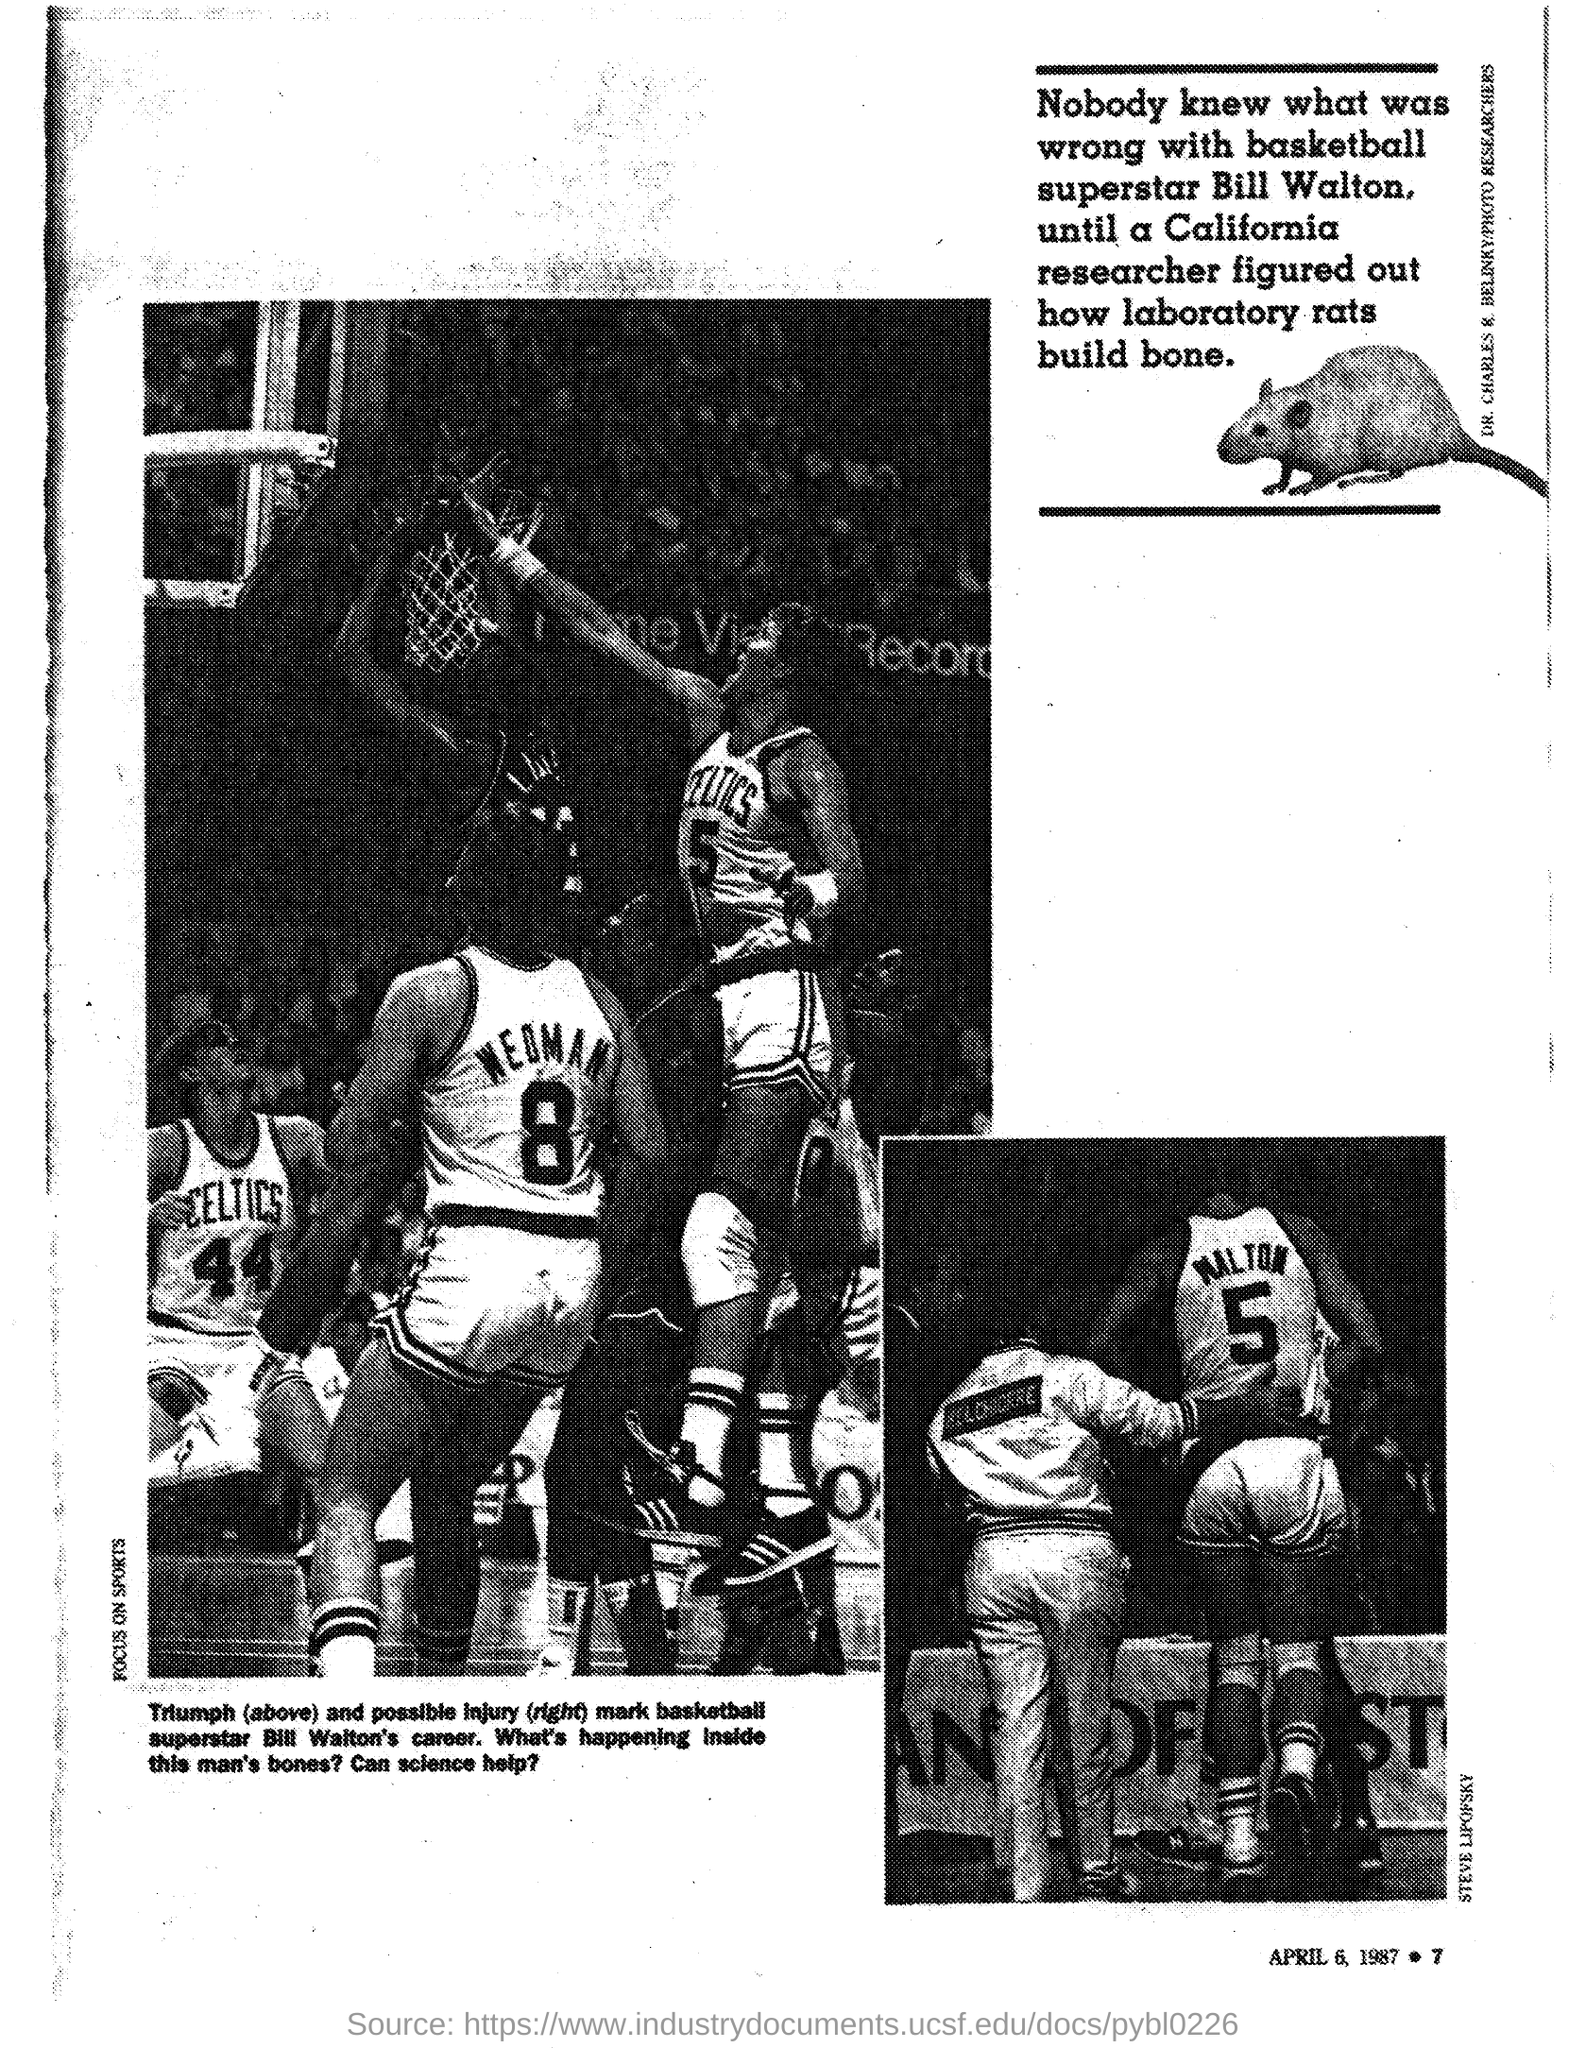Specify some key components in this picture. Bill Walton is the basketball superstar mentioned in the document. 